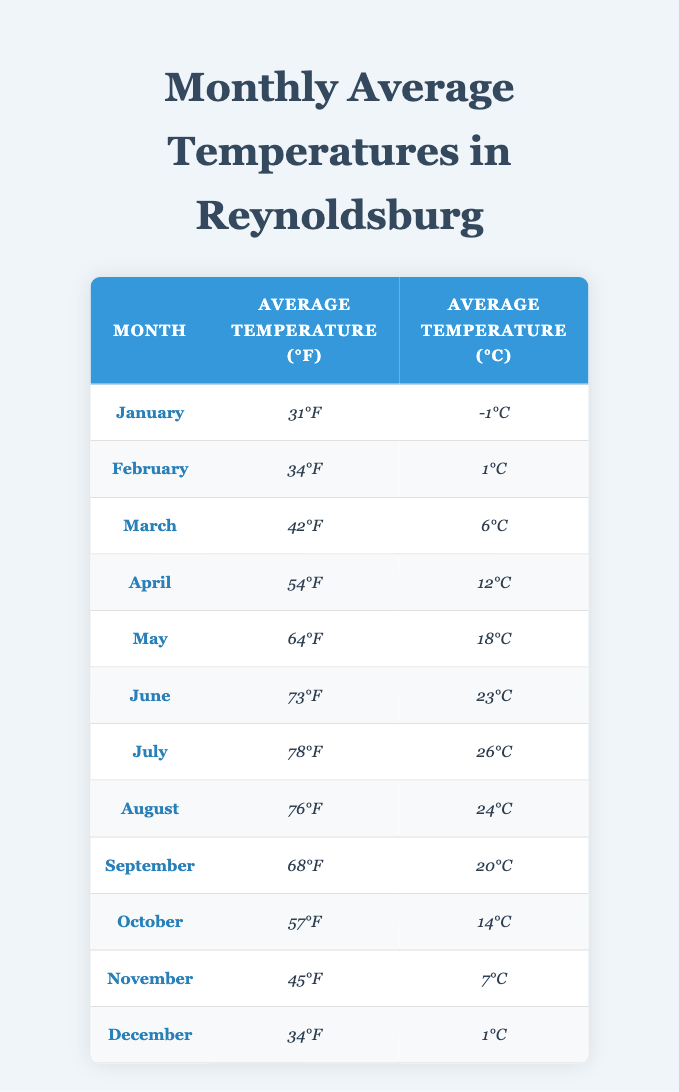What is the average temperature in June? The table shows June's average temperature as 73°F.
Answer: 73°F What is the lowest average temperature recorded? The lowest average temperature is in January at 31°F.
Answer: 31°F In which month does the average temperature first exceed 70°F? The average temperature exceeds 70°F in June (73°F).
Answer: June What is the difference in average temperature between July and December? July has an average temperature of 78°F and December has 34°F. The difference is 78 - 34 = 44°F.
Answer: 44°F Which month has the highest average temperature? July has the highest average temperature at 78°F.
Answer: July Is the average temperature in October higher than in March? October has an average temperature of 57°F, and March has 42°F. Since 57 is greater than 42, the answer is yes.
Answer: Yes What is the average temperature for the summer months (June, July, and August)? The average temperatures in June, July, and August are 73°F, 78°F, and 76°F, respectively. The average is (73 + 78 + 76) / 3 = 75.67°F.
Answer: 75.67°F How does the average temperature in October compare to the average temperature in April? October's temperature is 57°F and April's is 54°F. Since 57 is greater than 54, October is warmer than April.
Answer: October is warmer What is the sum of average temperatures from January to March? The average temperatures for January, February, and March are 31°F, 34°F, and 42°F. The sum is 31 + 34 + 42 = 107°F.
Answer: 107°F Is the average temperature in May below or above 60°F? May's average temperature is 64°F, which is above 60°F.
Answer: Above 60°F 